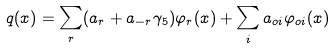Convert formula to latex. <formula><loc_0><loc_0><loc_500><loc_500>q ( x ) = \sum _ { r } ( a _ { r } + a _ { - r } \gamma _ { 5 } ) \varphi _ { r } ( x ) + \sum _ { i } a _ { o i } \varphi _ { o i } ( x )</formula> 